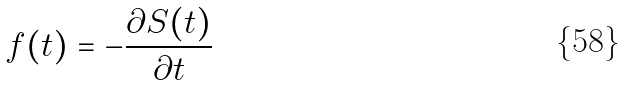<formula> <loc_0><loc_0><loc_500><loc_500>f ( t ) = - \frac { \partial S ( t ) } { \partial t }</formula> 